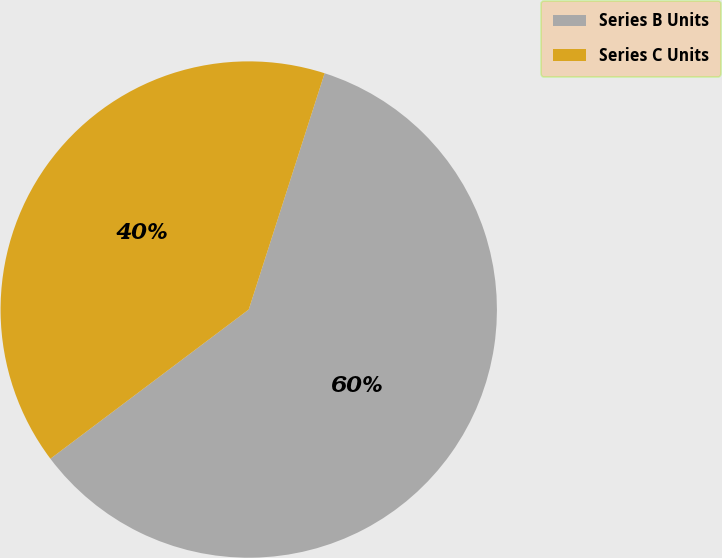<chart> <loc_0><loc_0><loc_500><loc_500><pie_chart><fcel>Series B Units<fcel>Series C Units<nl><fcel>59.79%<fcel>40.21%<nl></chart> 